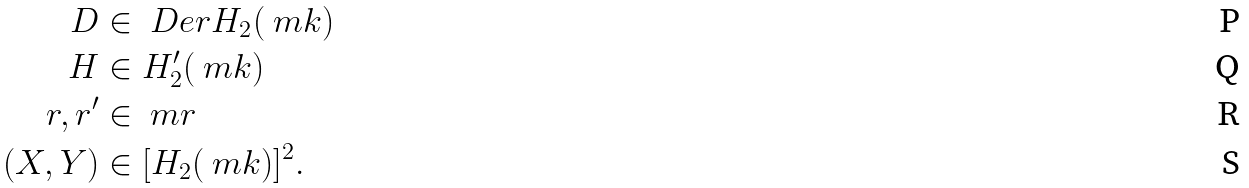Convert formula to latex. <formula><loc_0><loc_0><loc_500><loc_500>D & \in \ D e r H _ { 2 } ( \ m k ) \\ H & \in H _ { 2 } ^ { \prime } ( \ m k ) \\ r , r ^ { \prime } & \in \ m r \\ ( X , Y ) & \in [ H _ { 2 } ( \ m k ) ] ^ { 2 } .</formula> 